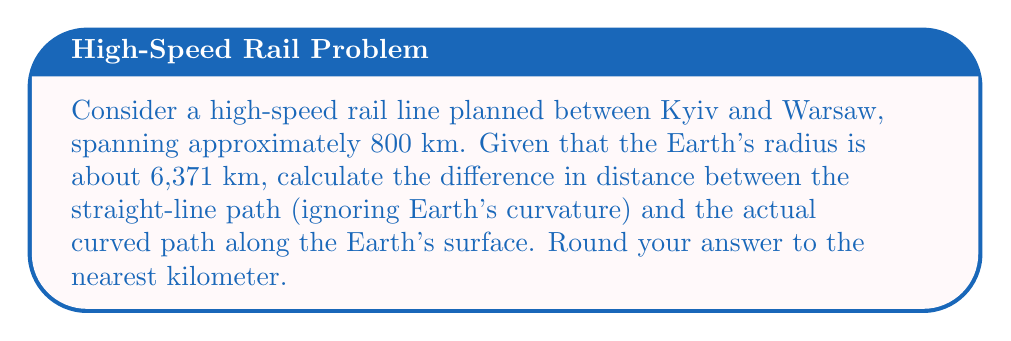Help me with this question. Let's approach this step-by-step:

1) First, we need to understand that the straight-line distance would be a chord of the Earth, while the actual path is an arc along the Earth's surface.

2) To calculate the arc length (s), we use the formula:
   $s = R\theta$
   where R is the Earth's radius and θ is the central angle in radians.

3) To find θ, we can use the chord length (c) formula:
   $c = 2R\sin(\frac{\theta}{2})$

4) We know c = 800 km and R = 6,371 km. Let's solve for θ:

   $800 = 2(6371)\sin(\frac{\theta}{2})$
   $\frac{400}{6371} = \sin(\frac{\theta}{2})$
   $\frac{\theta}{2} = \arcsin(\frac{400}{6371}) \approx 0.0628$ radians
   $\theta \approx 0.1256$ radians

5) Now we can calculate the arc length:
   $s = 6371 * 0.1256 \approx 800.19$ km

6) The difference between the arc and chord is:
   $800.19 - 800 = 0.19$ km

7) Rounding to the nearest kilometer gives us 0 km.

[asy]
import geometry;

pair O=(0,0);
real R=5;
path c=circle(O,R);
real ang=0.1256;
pair A=(R*cos(ang),R*sin(ang));
pair B=(R,0);

draw(c);
draw(O--A,blue);
draw(O--B,blue);
draw(A--B,red);
draw(arc(O,B,A),green);

label("O",O,SW);
label("Earth's center",O,S);
label("A",A,NE);
label("B",B,E);
label("Chord (straight line)",0.5*(A+B),SE,red);
label("Arc (Earth's surface)",0.5*(A+B),NW,green);

[/asy]
Answer: 0 km 